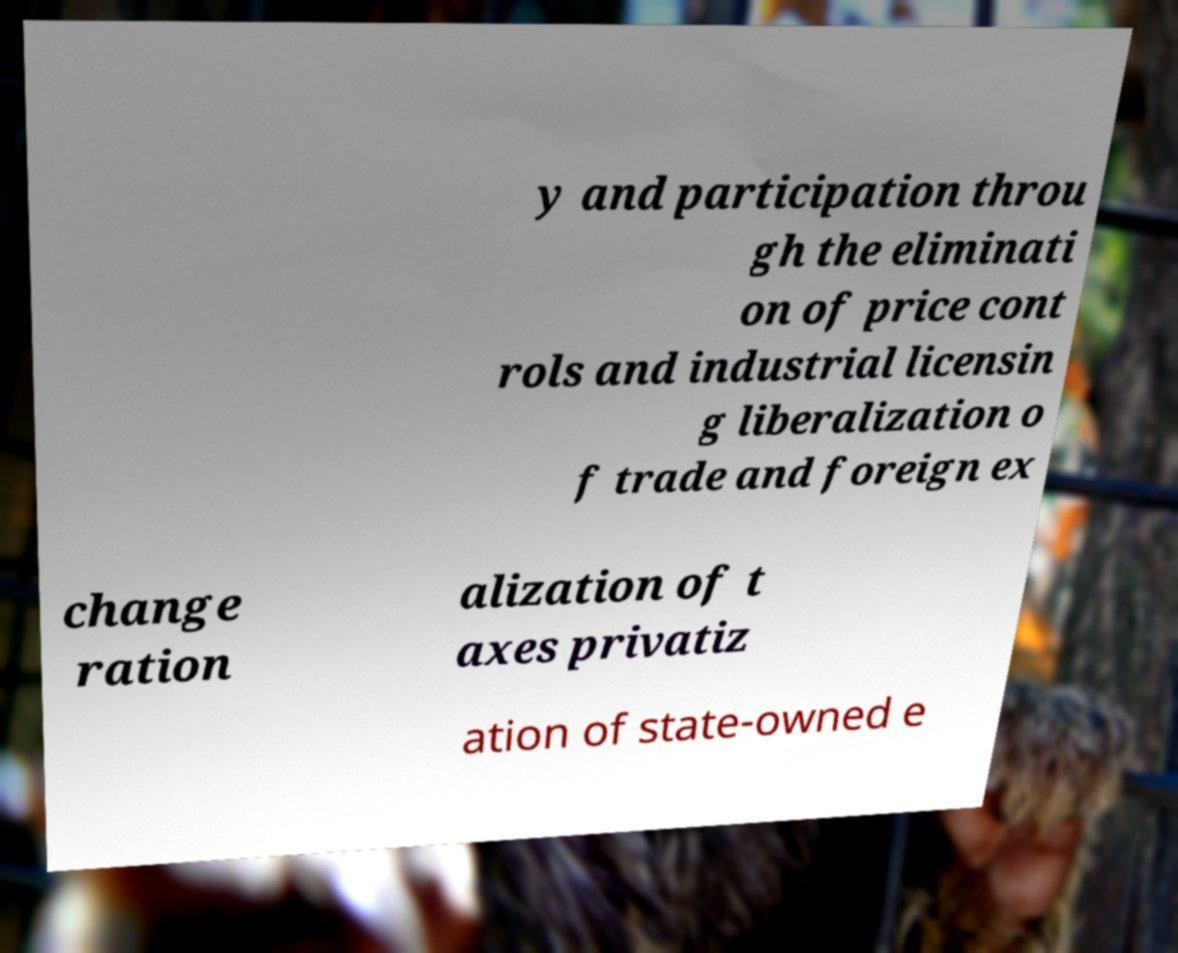There's text embedded in this image that I need extracted. Can you transcribe it verbatim? y and participation throu gh the eliminati on of price cont rols and industrial licensin g liberalization o f trade and foreign ex change ration alization of t axes privatiz ation of state-owned e 